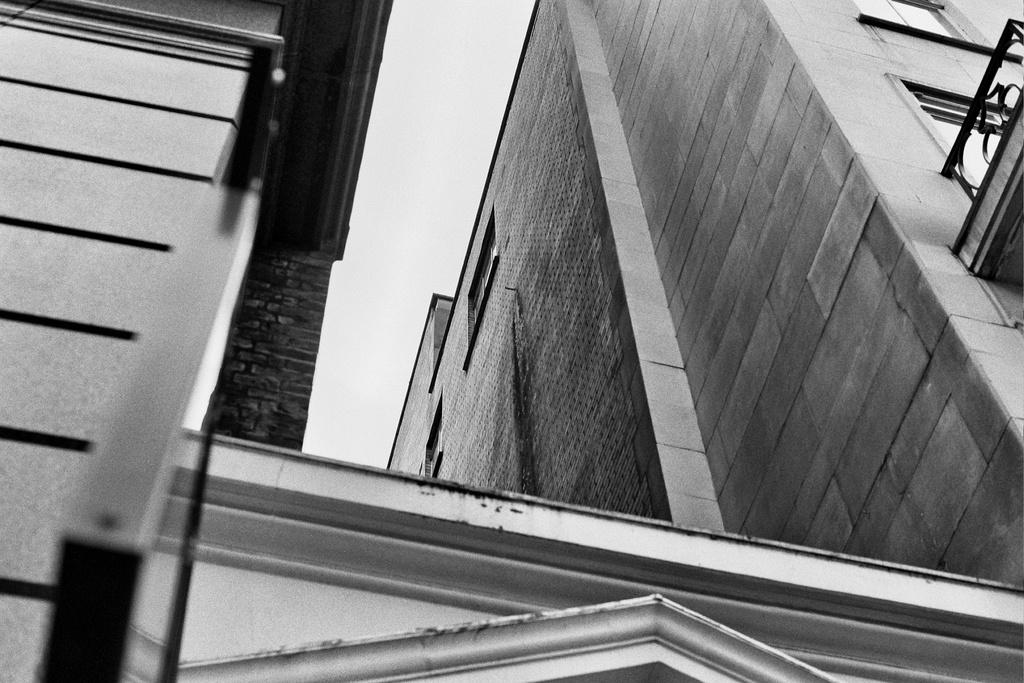What type of structure is visible in the image? There is a building in the image. What can be seen on the right side of the image? There is a railing on the right side of the image. What is on the left side of the image? There is a wall on the left side of the image. What is visible at the top of the image? The sky is visible at the top of the image. How does the sock contribute to the structure of the building in the image? There is no sock present in the image, so it cannot contribute to the structure of the building. 